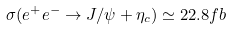<formula> <loc_0><loc_0><loc_500><loc_500>\sigma ( e ^ { + } e ^ { - } \to J / \psi + \eta _ { c } ) \simeq 2 2 . 8 f b</formula> 